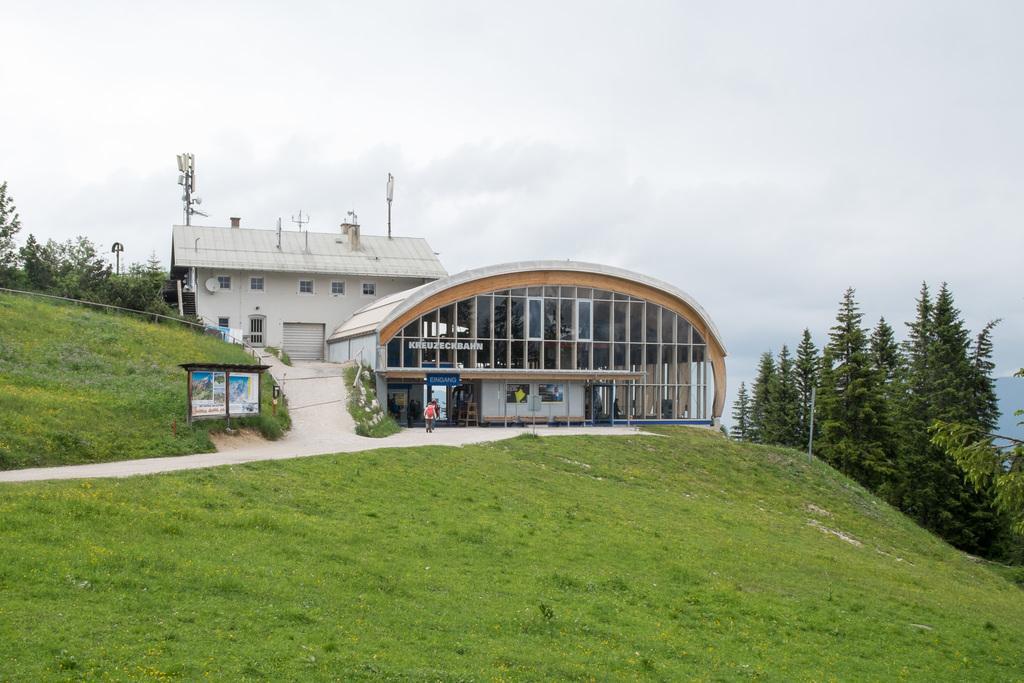In one or two sentences, can you explain what this image depicts? In this image we can see one white color building and a pole. Right side of the image trees are there. In front of the building and beside the building grassy land is present. The sky is covered with clouds. 